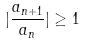<formula> <loc_0><loc_0><loc_500><loc_500>| \frac { a _ { n + 1 } } { a _ { n } } | \geq 1</formula> 